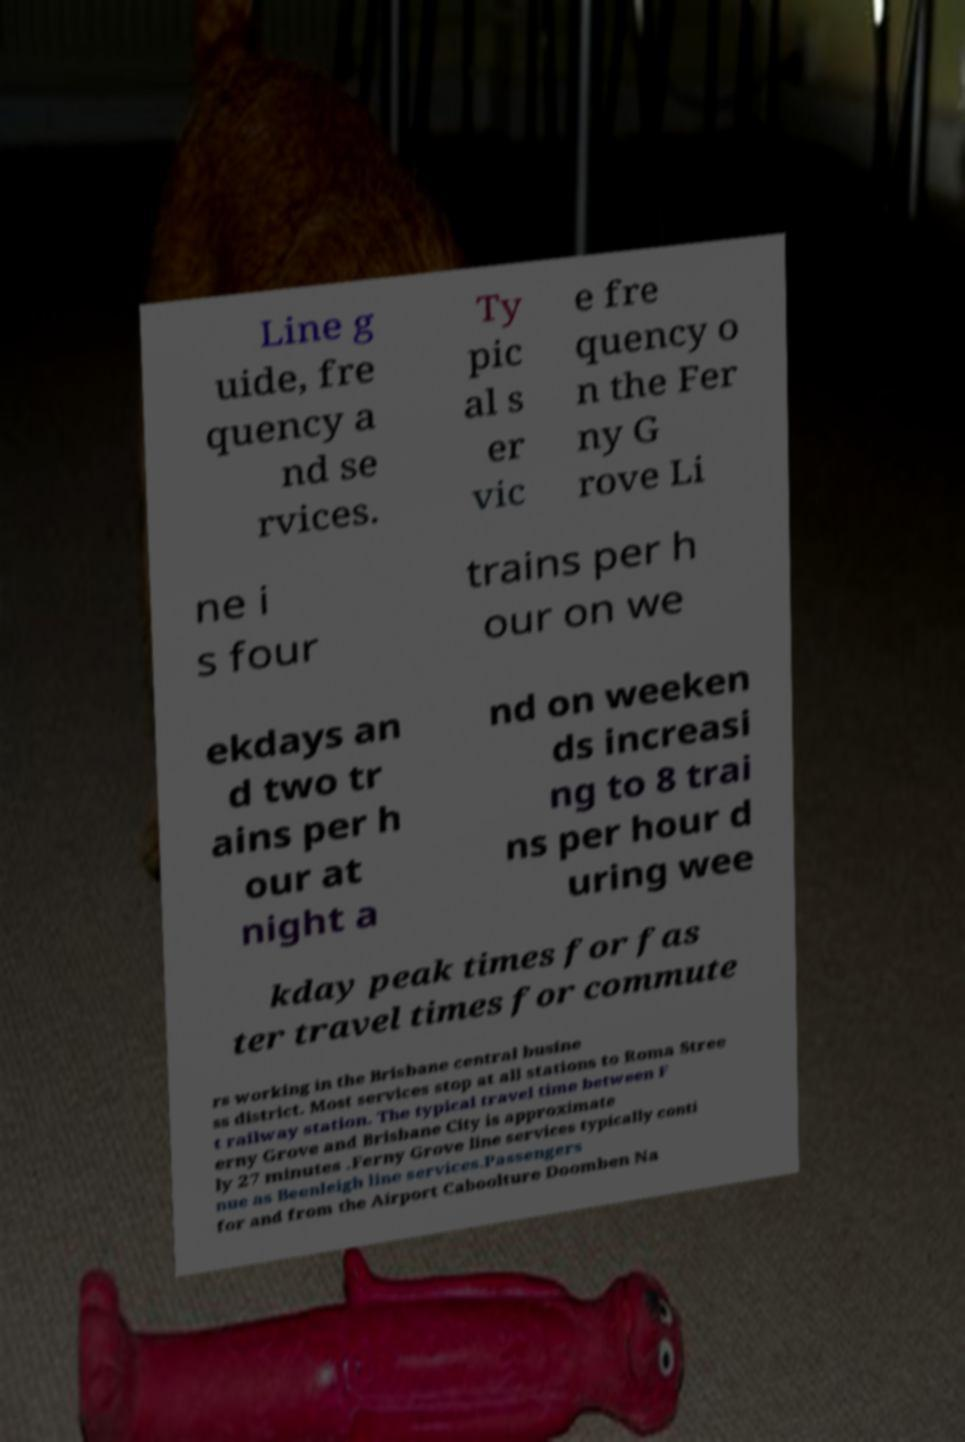What messages or text are displayed in this image? I need them in a readable, typed format. Line g uide, fre quency a nd se rvices. Ty pic al s er vic e fre quency o n the Fer ny G rove Li ne i s four trains per h our on we ekdays an d two tr ains per h our at night a nd on weeken ds increasi ng to 8 trai ns per hour d uring wee kday peak times for fas ter travel times for commute rs working in the Brisbane central busine ss district. Most services stop at all stations to Roma Stree t railway station. The typical travel time between F erny Grove and Brisbane City is approximate ly 27 minutes .Ferny Grove line services typically conti nue as Beenleigh line services.Passengers for and from the Airport Caboolture Doomben Na 